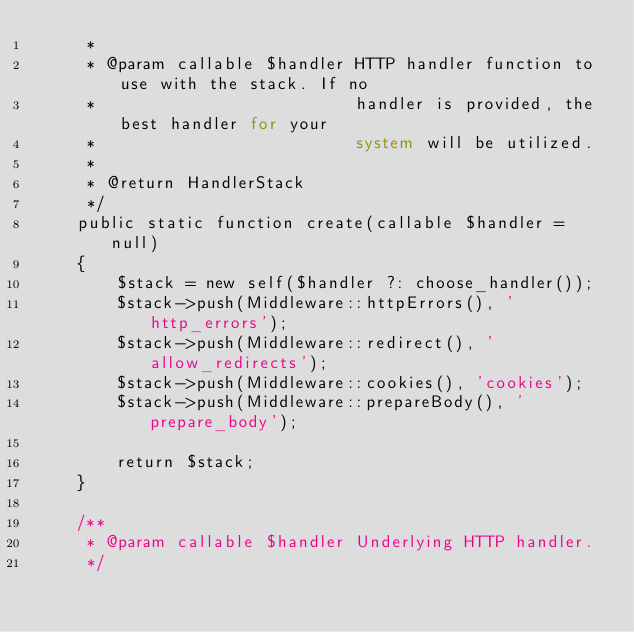<code> <loc_0><loc_0><loc_500><loc_500><_PHP_>     *
     * @param callable $handler HTTP handler function to use with the stack. If no
     *                          handler is provided, the best handler for your
     *                          system will be utilized.
     *
     * @return HandlerStack
     */
    public static function create(callable $handler = null)
    {
        $stack = new self($handler ?: choose_handler());
        $stack->push(Middleware::httpErrors(), 'http_errors');
        $stack->push(Middleware::redirect(), 'allow_redirects');
        $stack->push(Middleware::cookies(), 'cookies');
        $stack->push(Middleware::prepareBody(), 'prepare_body');

        return $stack;
    }

    /**
     * @param callable $handler Underlying HTTP handler.
     */</code> 